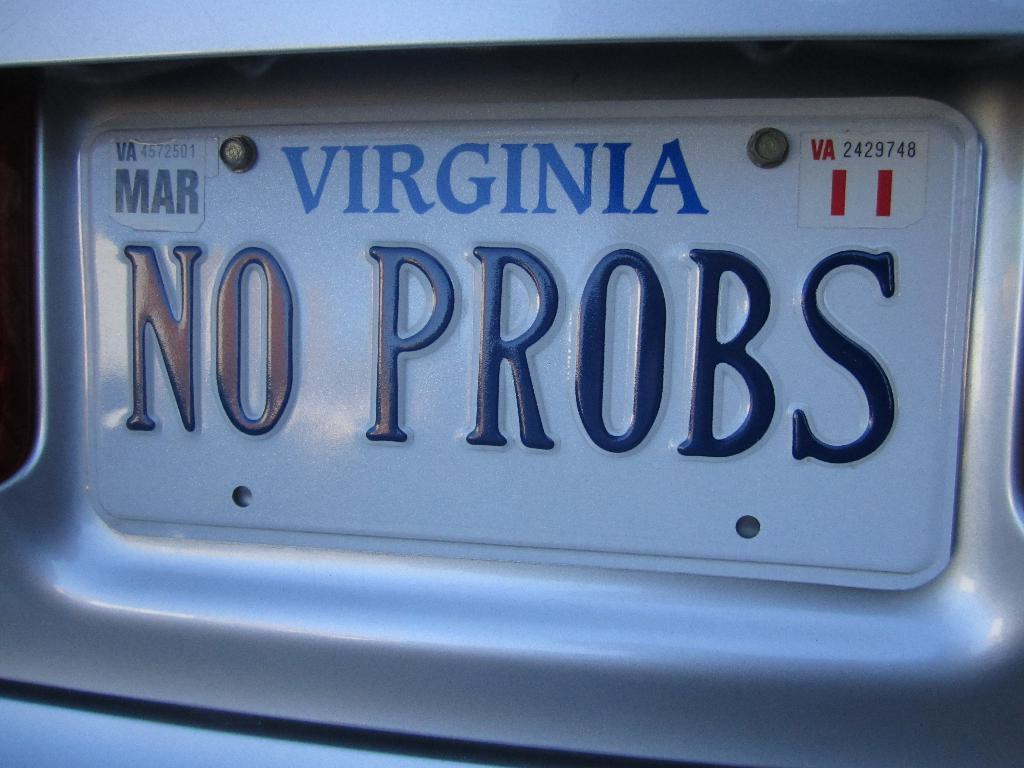<image>
Relay a brief, clear account of the picture shown. A Virginia license plate has the number 11 in the upper right corner. 